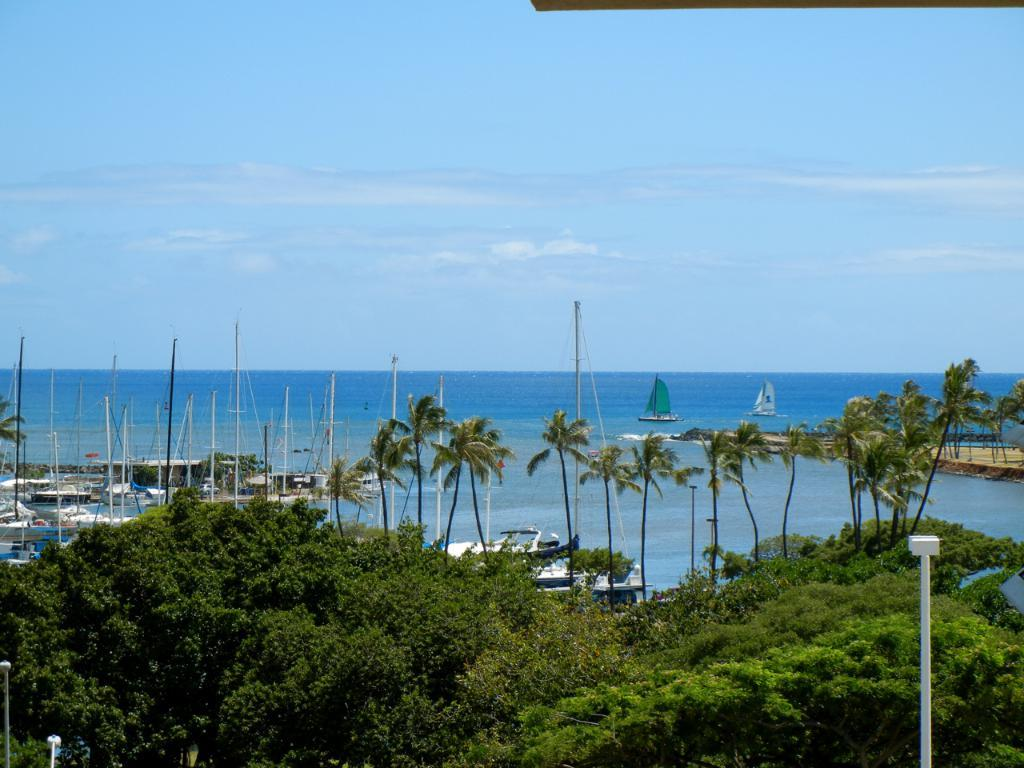What type of vegetation can be seen in the image? There are trees in the image. What are the white-colored objects in the image? There are white-colored poles in the image. What can be seen in the background of the image? There is water, trees, and the sky visible in the background of the image. What is on the surface of the water? There are boats on the surface of the water. What type of net is being used by the daughter in the image? There is no daughter present in the image, and therefore no net being used. What toys can be seen in the image? There are no toys visible in the image. 